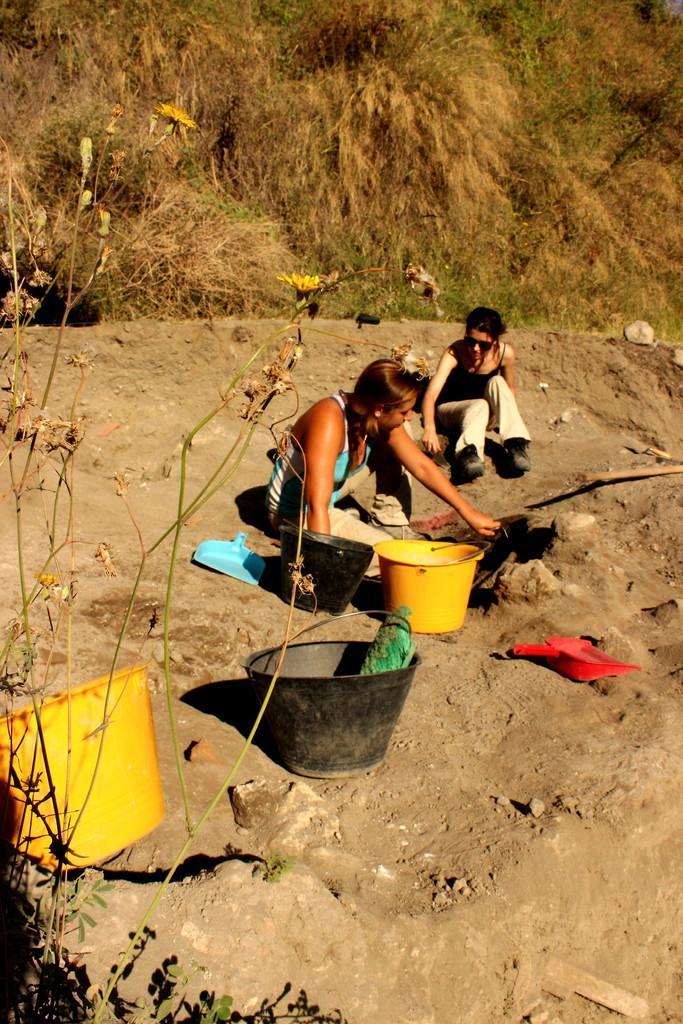Could you give a brief overview of what you see in this image? In the image we can see there are people sitting on the ground and there is mud on the ground. There are buckets and baskets kept on the ground. Behind there are dry plants. 